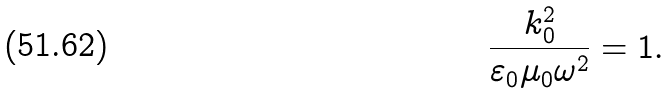Convert formula to latex. <formula><loc_0><loc_0><loc_500><loc_500>\frac { k _ { 0 } ^ { 2 } } { \varepsilon _ { 0 } \mu _ { 0 } \omega ^ { 2 } } = 1 .</formula> 